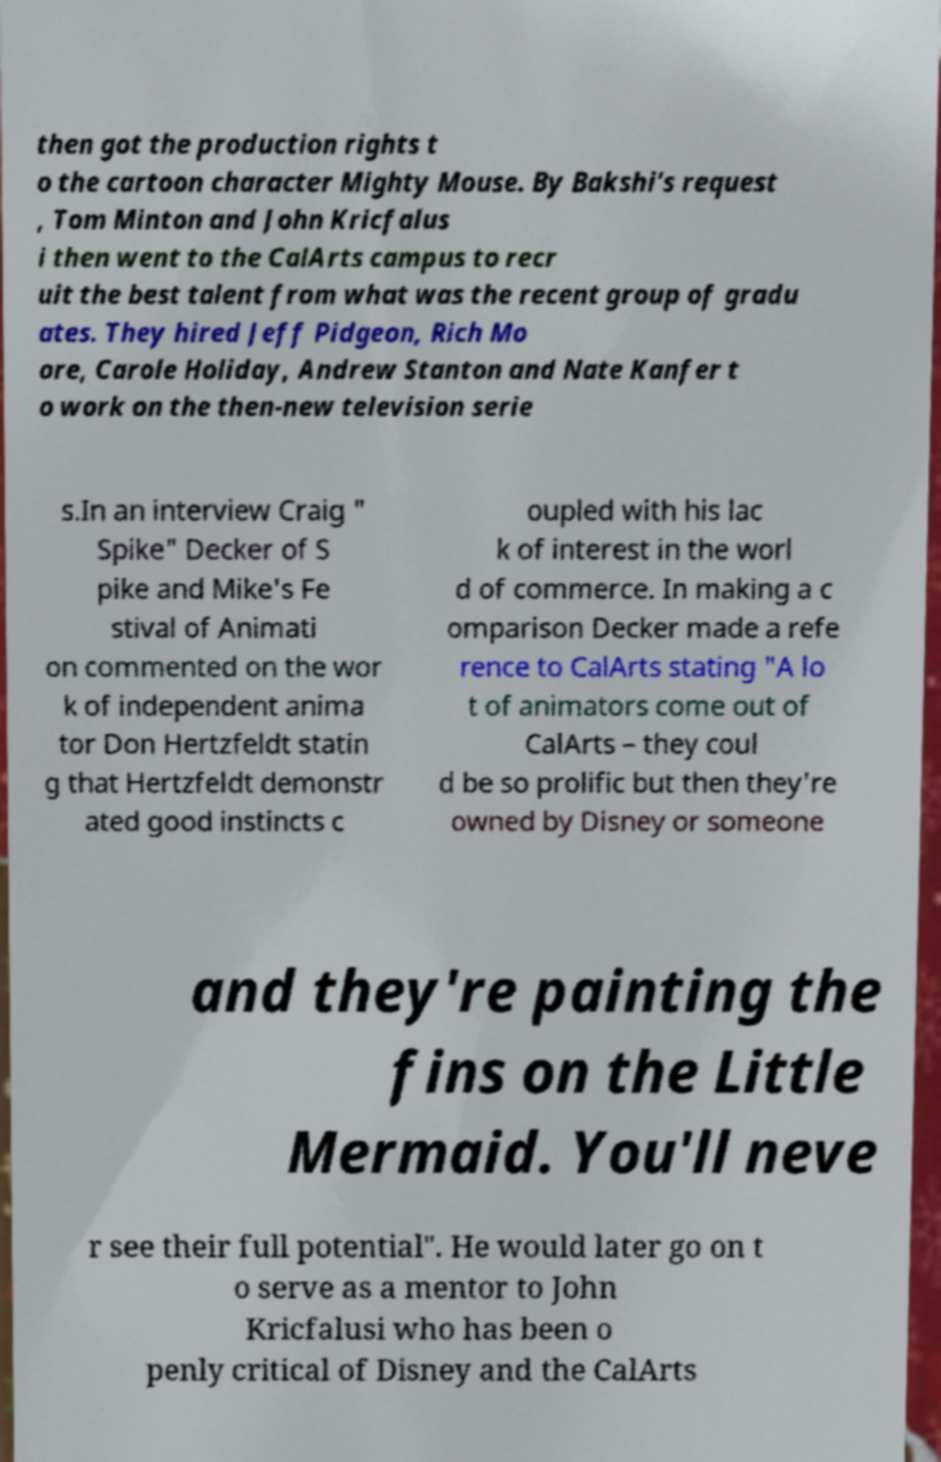Can you accurately transcribe the text from the provided image for me? then got the production rights t o the cartoon character Mighty Mouse. By Bakshi's request , Tom Minton and John Kricfalus i then went to the CalArts campus to recr uit the best talent from what was the recent group of gradu ates. They hired Jeff Pidgeon, Rich Mo ore, Carole Holiday, Andrew Stanton and Nate Kanfer t o work on the then-new television serie s.In an interview Craig " Spike" Decker of S pike and Mike's Fe stival of Animati on commented on the wor k of independent anima tor Don Hertzfeldt statin g that Hertzfeldt demonstr ated good instincts c oupled with his lac k of interest in the worl d of commerce. In making a c omparison Decker made a refe rence to CalArts stating "A lo t of animators come out of CalArts – they coul d be so prolific but then they're owned by Disney or someone and they're painting the fins on the Little Mermaid. You'll neve r see their full potential". He would later go on t o serve as a mentor to John Kricfalusi who has been o penly critical of Disney and the CalArts 